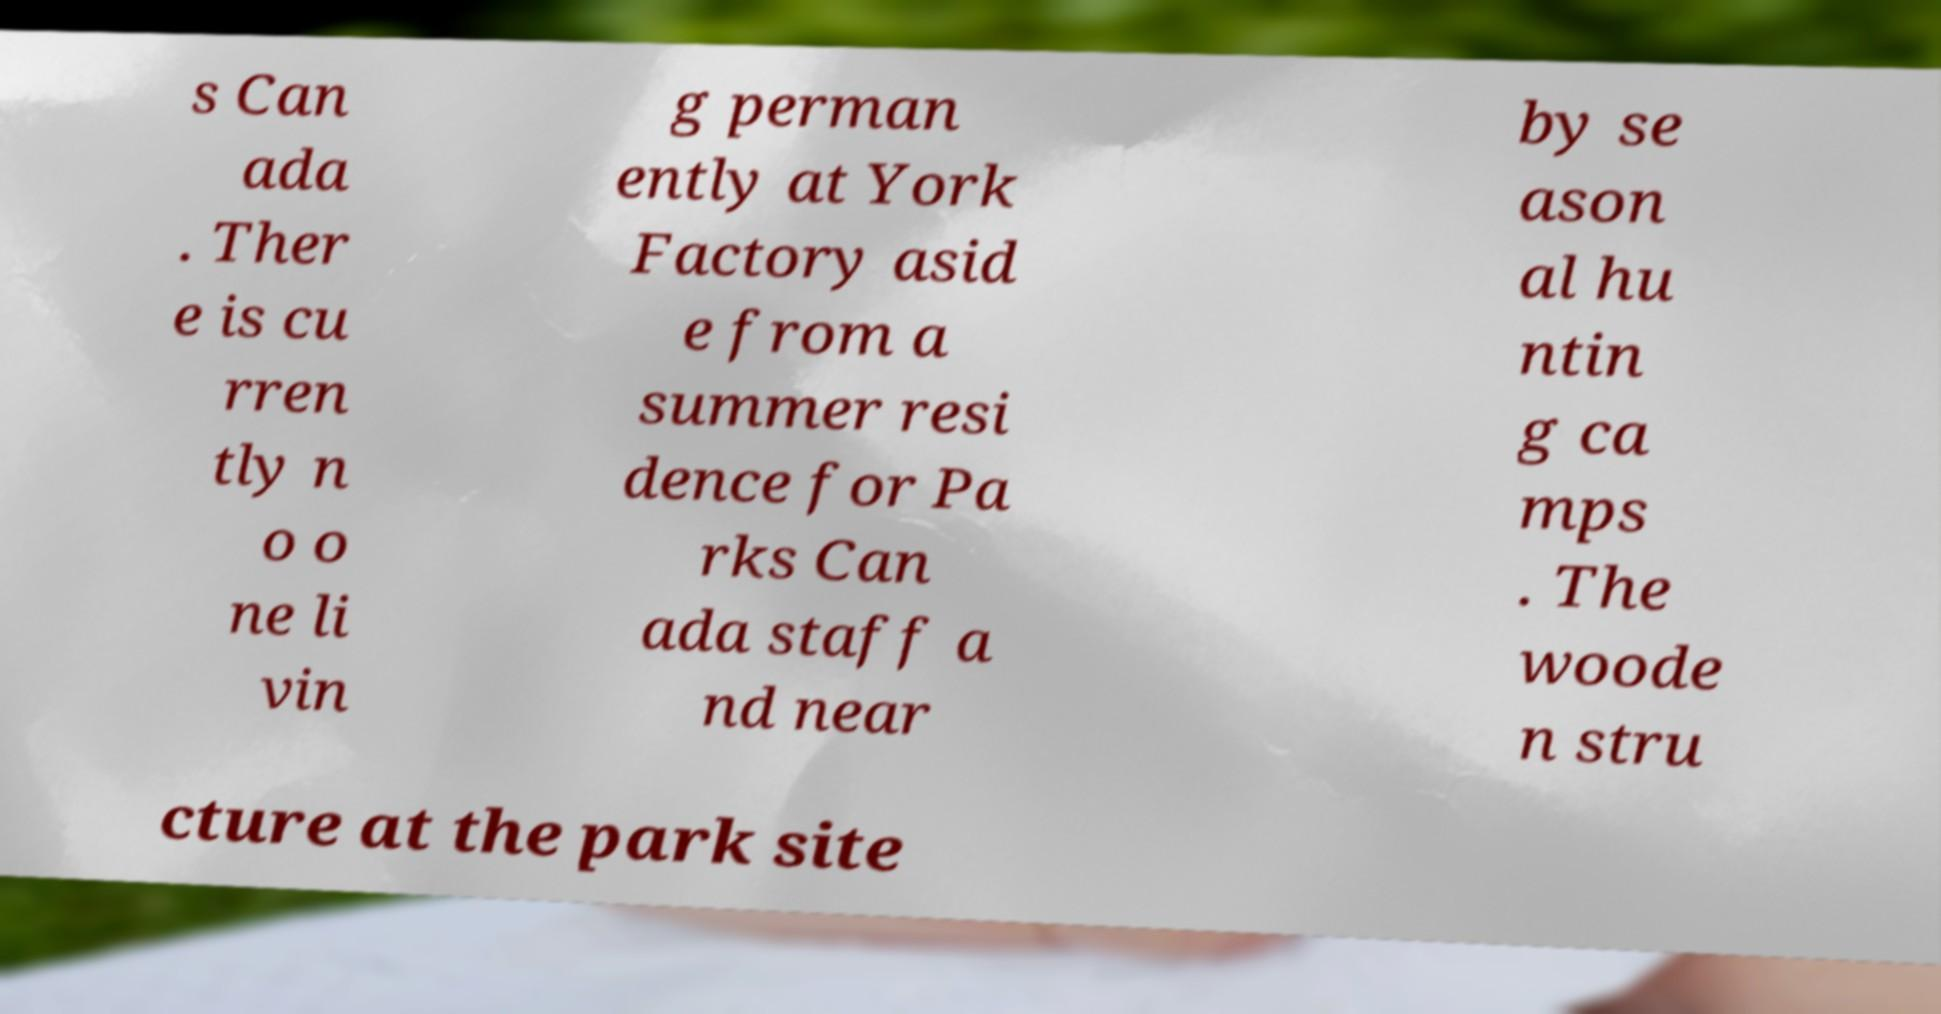Could you extract and type out the text from this image? s Can ada . Ther e is cu rren tly n o o ne li vin g perman ently at York Factory asid e from a summer resi dence for Pa rks Can ada staff a nd near by se ason al hu ntin g ca mps . The woode n stru cture at the park site 